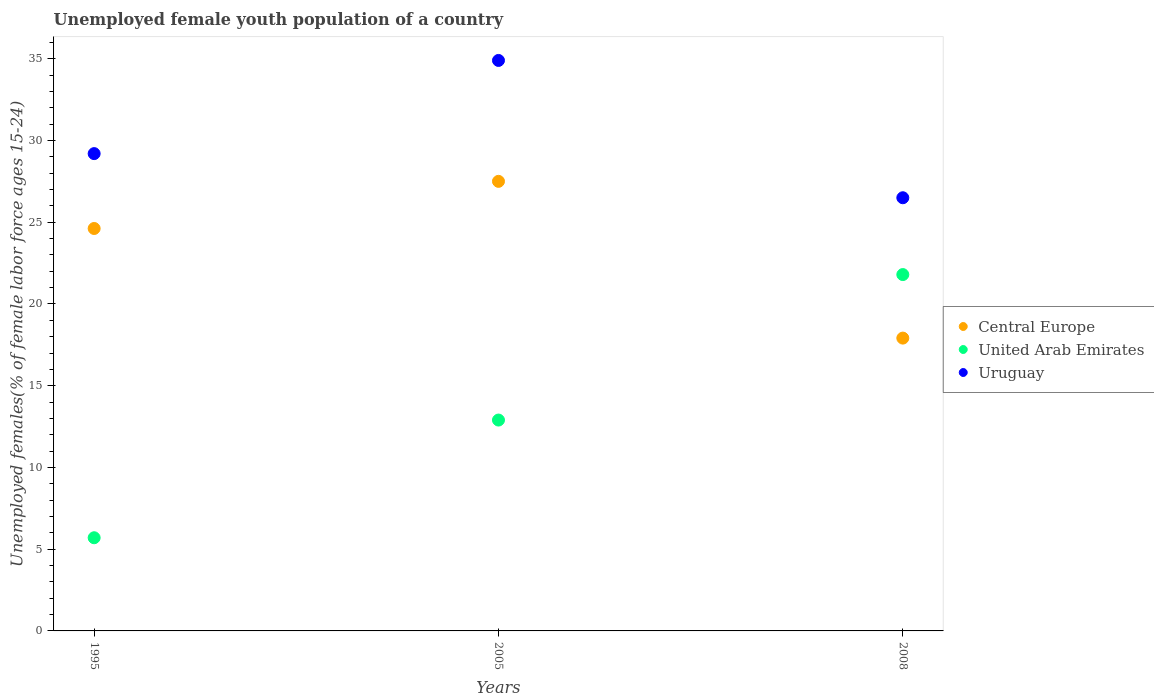How many different coloured dotlines are there?
Make the answer very short. 3. What is the percentage of unemployed female youth population in Uruguay in 1995?
Make the answer very short. 29.2. Across all years, what is the maximum percentage of unemployed female youth population in United Arab Emirates?
Your answer should be compact. 21.8. Across all years, what is the minimum percentage of unemployed female youth population in Central Europe?
Keep it short and to the point. 17.91. In which year was the percentage of unemployed female youth population in Uruguay minimum?
Your answer should be compact. 2008. What is the total percentage of unemployed female youth population in United Arab Emirates in the graph?
Your answer should be compact. 40.4. What is the difference between the percentage of unemployed female youth population in United Arab Emirates in 1995 and that in 2008?
Give a very brief answer. -16.1. What is the difference between the percentage of unemployed female youth population in Central Europe in 2005 and the percentage of unemployed female youth population in United Arab Emirates in 2008?
Offer a very short reply. 5.7. What is the average percentage of unemployed female youth population in Central Europe per year?
Provide a short and direct response. 23.35. In the year 1995, what is the difference between the percentage of unemployed female youth population in United Arab Emirates and percentage of unemployed female youth population in Uruguay?
Your answer should be compact. -23.5. In how many years, is the percentage of unemployed female youth population in Uruguay greater than 11 %?
Your answer should be compact. 3. What is the ratio of the percentage of unemployed female youth population in United Arab Emirates in 1995 to that in 2008?
Ensure brevity in your answer.  0.26. Is the percentage of unemployed female youth population in Uruguay in 1995 less than that in 2005?
Offer a very short reply. Yes. Is the difference between the percentage of unemployed female youth population in United Arab Emirates in 2005 and 2008 greater than the difference between the percentage of unemployed female youth population in Uruguay in 2005 and 2008?
Make the answer very short. No. What is the difference between the highest and the second highest percentage of unemployed female youth population in United Arab Emirates?
Ensure brevity in your answer.  8.9. What is the difference between the highest and the lowest percentage of unemployed female youth population in Central Europe?
Make the answer very short. 9.59. In how many years, is the percentage of unemployed female youth population in Uruguay greater than the average percentage of unemployed female youth population in Uruguay taken over all years?
Provide a short and direct response. 1. Is the sum of the percentage of unemployed female youth population in Central Europe in 2005 and 2008 greater than the maximum percentage of unemployed female youth population in United Arab Emirates across all years?
Your answer should be compact. Yes. Is it the case that in every year, the sum of the percentage of unemployed female youth population in United Arab Emirates and percentage of unemployed female youth population in Uruguay  is greater than the percentage of unemployed female youth population in Central Europe?
Make the answer very short. Yes. Does the percentage of unemployed female youth population in United Arab Emirates monotonically increase over the years?
Provide a succinct answer. Yes. Is the percentage of unemployed female youth population in Central Europe strictly less than the percentage of unemployed female youth population in United Arab Emirates over the years?
Give a very brief answer. No. What is the difference between two consecutive major ticks on the Y-axis?
Offer a terse response. 5. Are the values on the major ticks of Y-axis written in scientific E-notation?
Keep it short and to the point. No. Does the graph contain any zero values?
Give a very brief answer. No. Does the graph contain grids?
Provide a short and direct response. No. Where does the legend appear in the graph?
Ensure brevity in your answer.  Center right. How many legend labels are there?
Offer a very short reply. 3. What is the title of the graph?
Keep it short and to the point. Unemployed female youth population of a country. What is the label or title of the Y-axis?
Offer a terse response. Unemployed females(% of female labor force ages 15-24). What is the Unemployed females(% of female labor force ages 15-24) of Central Europe in 1995?
Provide a succinct answer. 24.62. What is the Unemployed females(% of female labor force ages 15-24) in United Arab Emirates in 1995?
Ensure brevity in your answer.  5.7. What is the Unemployed females(% of female labor force ages 15-24) in Uruguay in 1995?
Provide a short and direct response. 29.2. What is the Unemployed females(% of female labor force ages 15-24) of Central Europe in 2005?
Provide a short and direct response. 27.5. What is the Unemployed females(% of female labor force ages 15-24) in United Arab Emirates in 2005?
Offer a very short reply. 12.9. What is the Unemployed females(% of female labor force ages 15-24) of Uruguay in 2005?
Offer a very short reply. 34.9. What is the Unemployed females(% of female labor force ages 15-24) in Central Europe in 2008?
Your answer should be very brief. 17.91. What is the Unemployed females(% of female labor force ages 15-24) of United Arab Emirates in 2008?
Offer a terse response. 21.8. What is the Unemployed females(% of female labor force ages 15-24) of Uruguay in 2008?
Make the answer very short. 26.5. Across all years, what is the maximum Unemployed females(% of female labor force ages 15-24) in Central Europe?
Provide a short and direct response. 27.5. Across all years, what is the maximum Unemployed females(% of female labor force ages 15-24) of United Arab Emirates?
Make the answer very short. 21.8. Across all years, what is the maximum Unemployed females(% of female labor force ages 15-24) in Uruguay?
Give a very brief answer. 34.9. Across all years, what is the minimum Unemployed females(% of female labor force ages 15-24) in Central Europe?
Offer a very short reply. 17.91. Across all years, what is the minimum Unemployed females(% of female labor force ages 15-24) of United Arab Emirates?
Offer a very short reply. 5.7. What is the total Unemployed females(% of female labor force ages 15-24) in Central Europe in the graph?
Make the answer very short. 70.04. What is the total Unemployed females(% of female labor force ages 15-24) of United Arab Emirates in the graph?
Your response must be concise. 40.4. What is the total Unemployed females(% of female labor force ages 15-24) of Uruguay in the graph?
Offer a terse response. 90.6. What is the difference between the Unemployed females(% of female labor force ages 15-24) in Central Europe in 1995 and that in 2005?
Your answer should be compact. -2.88. What is the difference between the Unemployed females(% of female labor force ages 15-24) of United Arab Emirates in 1995 and that in 2005?
Your answer should be compact. -7.2. What is the difference between the Unemployed females(% of female labor force ages 15-24) of Uruguay in 1995 and that in 2005?
Make the answer very short. -5.7. What is the difference between the Unemployed females(% of female labor force ages 15-24) in Central Europe in 1995 and that in 2008?
Ensure brevity in your answer.  6.71. What is the difference between the Unemployed females(% of female labor force ages 15-24) of United Arab Emirates in 1995 and that in 2008?
Provide a succinct answer. -16.1. What is the difference between the Unemployed females(% of female labor force ages 15-24) in Uruguay in 1995 and that in 2008?
Your answer should be very brief. 2.7. What is the difference between the Unemployed females(% of female labor force ages 15-24) of Central Europe in 2005 and that in 2008?
Offer a terse response. 9.59. What is the difference between the Unemployed females(% of female labor force ages 15-24) in Uruguay in 2005 and that in 2008?
Your answer should be very brief. 8.4. What is the difference between the Unemployed females(% of female labor force ages 15-24) of Central Europe in 1995 and the Unemployed females(% of female labor force ages 15-24) of United Arab Emirates in 2005?
Your answer should be very brief. 11.72. What is the difference between the Unemployed females(% of female labor force ages 15-24) of Central Europe in 1995 and the Unemployed females(% of female labor force ages 15-24) of Uruguay in 2005?
Your answer should be compact. -10.28. What is the difference between the Unemployed females(% of female labor force ages 15-24) of United Arab Emirates in 1995 and the Unemployed females(% of female labor force ages 15-24) of Uruguay in 2005?
Your answer should be compact. -29.2. What is the difference between the Unemployed females(% of female labor force ages 15-24) of Central Europe in 1995 and the Unemployed females(% of female labor force ages 15-24) of United Arab Emirates in 2008?
Your answer should be very brief. 2.82. What is the difference between the Unemployed females(% of female labor force ages 15-24) in Central Europe in 1995 and the Unemployed females(% of female labor force ages 15-24) in Uruguay in 2008?
Provide a short and direct response. -1.88. What is the difference between the Unemployed females(% of female labor force ages 15-24) of United Arab Emirates in 1995 and the Unemployed females(% of female labor force ages 15-24) of Uruguay in 2008?
Your answer should be very brief. -20.8. What is the difference between the Unemployed females(% of female labor force ages 15-24) in Central Europe in 2005 and the Unemployed females(% of female labor force ages 15-24) in United Arab Emirates in 2008?
Make the answer very short. 5.7. What is the difference between the Unemployed females(% of female labor force ages 15-24) in Central Europe in 2005 and the Unemployed females(% of female labor force ages 15-24) in Uruguay in 2008?
Offer a very short reply. 1. What is the average Unemployed females(% of female labor force ages 15-24) in Central Europe per year?
Keep it short and to the point. 23.35. What is the average Unemployed females(% of female labor force ages 15-24) of United Arab Emirates per year?
Offer a terse response. 13.47. What is the average Unemployed females(% of female labor force ages 15-24) of Uruguay per year?
Your answer should be very brief. 30.2. In the year 1995, what is the difference between the Unemployed females(% of female labor force ages 15-24) of Central Europe and Unemployed females(% of female labor force ages 15-24) of United Arab Emirates?
Your answer should be very brief. 18.92. In the year 1995, what is the difference between the Unemployed females(% of female labor force ages 15-24) of Central Europe and Unemployed females(% of female labor force ages 15-24) of Uruguay?
Your answer should be very brief. -4.58. In the year 1995, what is the difference between the Unemployed females(% of female labor force ages 15-24) in United Arab Emirates and Unemployed females(% of female labor force ages 15-24) in Uruguay?
Offer a terse response. -23.5. In the year 2005, what is the difference between the Unemployed females(% of female labor force ages 15-24) of Central Europe and Unemployed females(% of female labor force ages 15-24) of United Arab Emirates?
Make the answer very short. 14.6. In the year 2005, what is the difference between the Unemployed females(% of female labor force ages 15-24) in Central Europe and Unemployed females(% of female labor force ages 15-24) in Uruguay?
Offer a very short reply. -7.4. In the year 2008, what is the difference between the Unemployed females(% of female labor force ages 15-24) in Central Europe and Unemployed females(% of female labor force ages 15-24) in United Arab Emirates?
Ensure brevity in your answer.  -3.89. In the year 2008, what is the difference between the Unemployed females(% of female labor force ages 15-24) in Central Europe and Unemployed females(% of female labor force ages 15-24) in Uruguay?
Make the answer very short. -8.59. What is the ratio of the Unemployed females(% of female labor force ages 15-24) in Central Europe in 1995 to that in 2005?
Make the answer very short. 0.9. What is the ratio of the Unemployed females(% of female labor force ages 15-24) in United Arab Emirates in 1995 to that in 2005?
Offer a very short reply. 0.44. What is the ratio of the Unemployed females(% of female labor force ages 15-24) of Uruguay in 1995 to that in 2005?
Your answer should be very brief. 0.84. What is the ratio of the Unemployed females(% of female labor force ages 15-24) of Central Europe in 1995 to that in 2008?
Your response must be concise. 1.37. What is the ratio of the Unemployed females(% of female labor force ages 15-24) of United Arab Emirates in 1995 to that in 2008?
Your answer should be very brief. 0.26. What is the ratio of the Unemployed females(% of female labor force ages 15-24) in Uruguay in 1995 to that in 2008?
Your response must be concise. 1.1. What is the ratio of the Unemployed females(% of female labor force ages 15-24) of Central Europe in 2005 to that in 2008?
Offer a terse response. 1.54. What is the ratio of the Unemployed females(% of female labor force ages 15-24) of United Arab Emirates in 2005 to that in 2008?
Your response must be concise. 0.59. What is the ratio of the Unemployed females(% of female labor force ages 15-24) of Uruguay in 2005 to that in 2008?
Your answer should be compact. 1.32. What is the difference between the highest and the second highest Unemployed females(% of female labor force ages 15-24) of Central Europe?
Offer a very short reply. 2.88. What is the difference between the highest and the second highest Unemployed females(% of female labor force ages 15-24) in Uruguay?
Your answer should be very brief. 5.7. What is the difference between the highest and the lowest Unemployed females(% of female labor force ages 15-24) of Central Europe?
Make the answer very short. 9.59. 